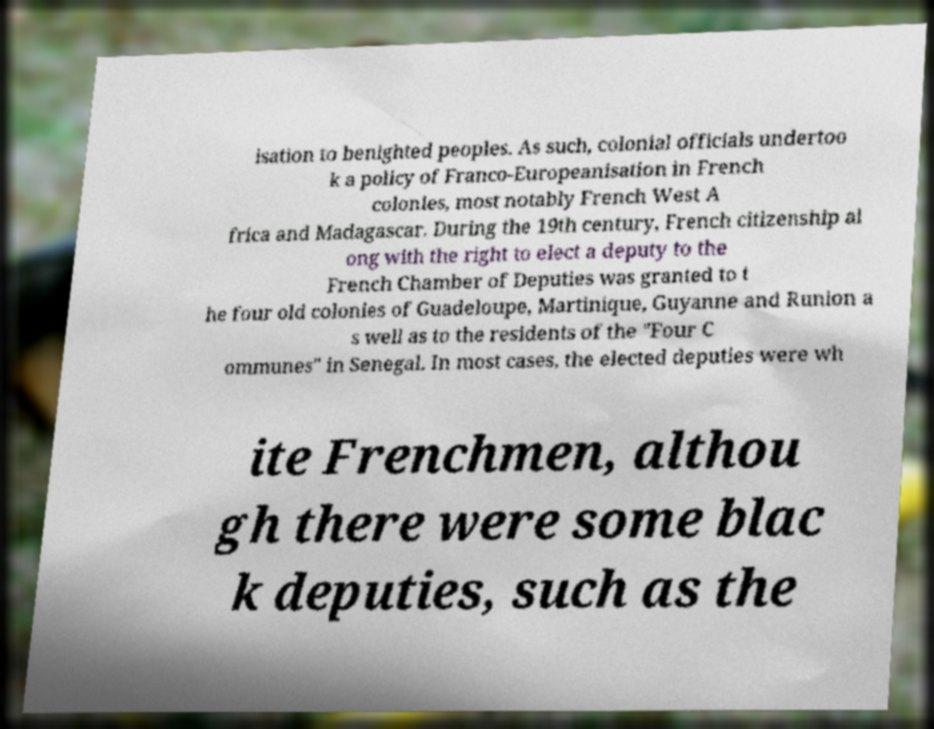Could you extract and type out the text from this image? isation to benighted peoples. As such, colonial officials undertoo k a policy of Franco-Europeanisation in French colonies, most notably French West A frica and Madagascar. During the 19th century, French citizenship al ong with the right to elect a deputy to the French Chamber of Deputies was granted to t he four old colonies of Guadeloupe, Martinique, Guyanne and Runion a s well as to the residents of the "Four C ommunes" in Senegal. In most cases, the elected deputies were wh ite Frenchmen, althou gh there were some blac k deputies, such as the 